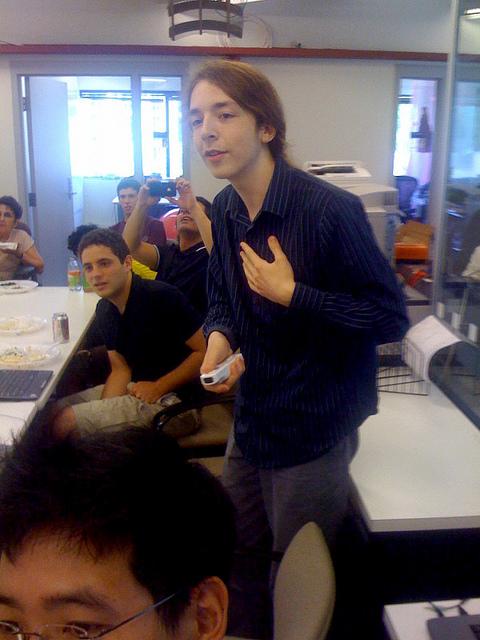What game system is this man using?
Answer briefly. Wii. Where are these kids?
Give a very brief answer. School. Who is holding a camera?
Give a very brief answer. Man. 